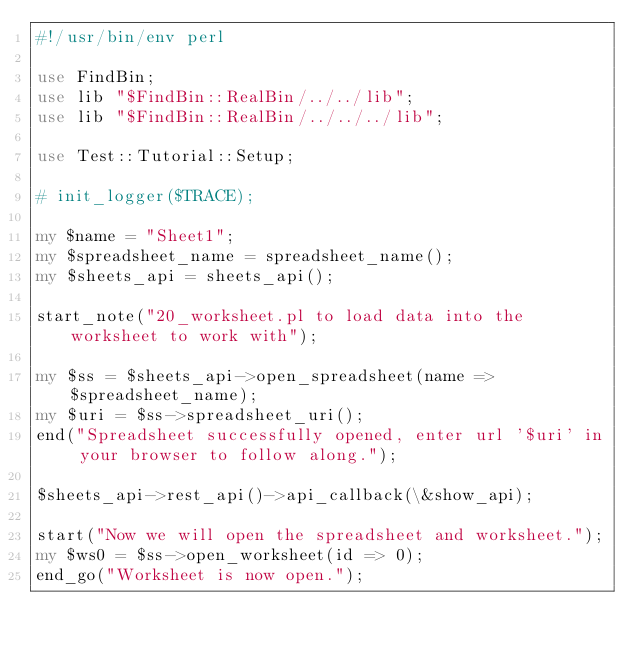<code> <loc_0><loc_0><loc_500><loc_500><_Perl_>#!/usr/bin/env perl

use FindBin;
use lib "$FindBin::RealBin/../../lib";
use lib "$FindBin::RealBin/../../../lib";

use Test::Tutorial::Setup;

# init_logger($TRACE);

my $name = "Sheet1";
my $spreadsheet_name = spreadsheet_name();
my $sheets_api = sheets_api();

start_note("20_worksheet.pl to load data into the worksheet to work with");

my $ss = $sheets_api->open_spreadsheet(name => $spreadsheet_name);
my $uri = $ss->spreadsheet_uri();
end("Spreadsheet successfully opened, enter url '$uri' in your browser to follow along.");

$sheets_api->rest_api()->api_callback(\&show_api);

start("Now we will open the spreadsheet and worksheet.");
my $ws0 = $ss->open_worksheet(id => 0);
end_go("Worksheet is now open.");
</code> 